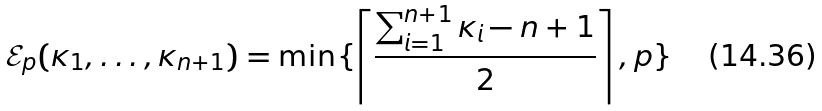Convert formula to latex. <formula><loc_0><loc_0><loc_500><loc_500>\mathcal { E } _ { p } ( \kappa _ { 1 } , \dots , \kappa _ { n + 1 } ) = \min \{ \left \lceil \frac { \sum _ { i = 1 } ^ { n + 1 } \kappa _ { i } - n + 1 } { 2 } \right \rceil , p \}</formula> 